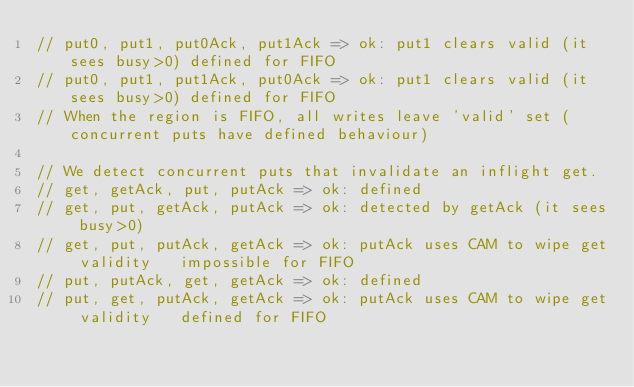Convert code to text. <code><loc_0><loc_0><loc_500><loc_500><_Scala_>// put0, put1, put0Ack, put1Ack => ok: put1 clears valid (it sees busy>0)	defined for FIFO
// put0, put1, put1Ack, put0Ack => ok: put1 clears valid (it sees busy>0)	defined for FIFO
// When the region is FIFO, all writes leave 'valid' set (concurrent puts have defined behaviour)

// We detect concurrent puts that invalidate an inflight get.
// get, getAck, put, putAck => ok: defined
// get, put, getAck, putAck => ok: detected by getAck (it sees busy>0)
// get, put, putAck, getAck => ok: putAck uses CAM to wipe get validity		impossible for FIFO
// put, putAck, get, getAck => ok: defined
// put, get, putAck, getAck => ok: putAck uses CAM to wipe get validity		defined for FIFO</code> 